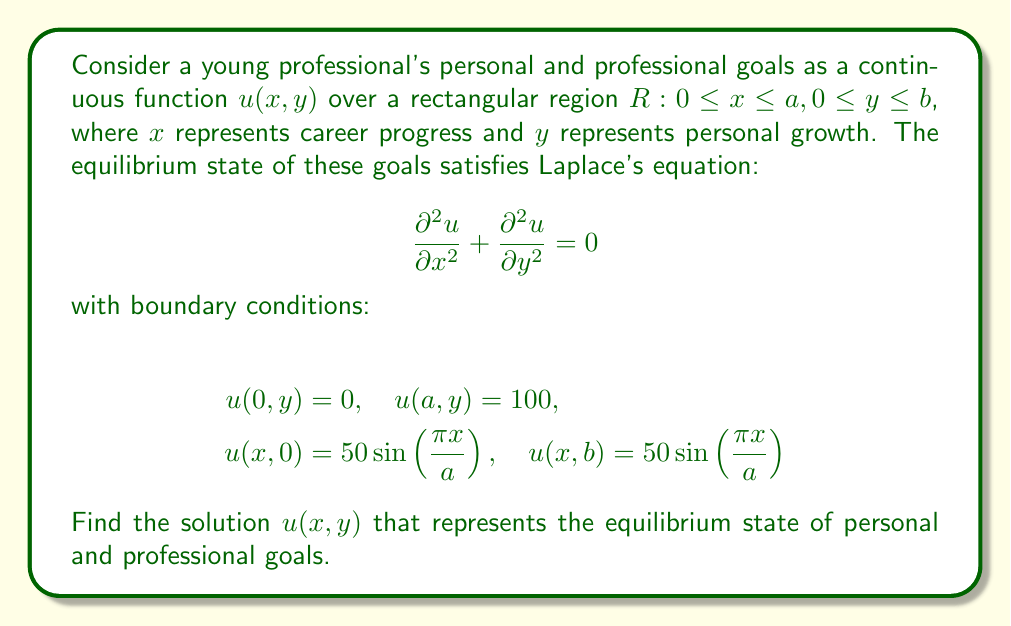Help me with this question. To solve this problem, we'll use the method of separation of variables.

1) Assume the solution has the form $u(x,y) = X(x)Y(y)$

2) Substituting into Laplace's equation:

   $$X''(x)Y(y) + X(x)Y''(y) = 0$$
   $$\frac{X''(x)}{X(x)} = -\frac{Y''(y)}{Y(y)} = -\lambda^2$$

3) This gives us two ODEs:
   $$X''(x) + \lambda^2X(x) = 0$$
   $$Y''(y) - \lambda^2Y(y) = 0$$

4) The general solutions are:
   $$X(x) = A\sin(\lambda x) + B\cos(\lambda x)$$
   $$Y(y) = Ce^{\lambda y} + De^{-\lambda y}$$

5) Applying the boundary conditions $u(0,y) = 0$ and $u(a,y) = 100$:
   $$X(0) = 0 \implies B = 0$$
   $$X(a) = 100 \implies A\sin(\lambda a) = 100$$

6) This means $\lambda = \frac{n\pi}{a}$ for $n = 1,2,3,...$

7) The solution that satisfies these conditions is:
   $$u(x,y) = \sum_{n=1}^{\infty} (C_n\sinh(\frac{n\pi y}{a}) + D_n\cosh(\frac{n\pi y}{a}))\sin(\frac{n\pi x}{a})$$

8) Applying the remaining boundary conditions:
   $$u(x,0) = 50\sin(\frac{\pi x}{a}) \implies D_1 = 50, D_n = 0 \text{ for } n > 1$$
   $$u(x,b) = 50\sin(\frac{\pi x}{a}) \implies C_1\sinh(\frac{\pi b}{a}) + 50\cosh(\frac{\pi b}{a}) = 50$$

9) Solving for $C_1$:
   $$C_1 = 50\frac{1-\cosh(\frac{\pi b}{a})}{\sinh(\frac{\pi b}{a})}$$

Therefore, the final solution is:
$$u(x,y) = 50\left(\frac{1-\cosh(\frac{\pi b}{a})}{\sinh(\frac{\pi b}{a})}\sinh(\frac{\pi y}{a}) + \cosh(\frac{\pi y}{a})\right)\sin(\frac{\pi x}{a})$$
Answer: $$u(x,y) = 50\left(\frac{1-\cosh(\frac{\pi b}{a})}{\sinh(\frac{\pi b}{a})}\sinh(\frac{\pi y}{a}) + \cosh(\frac{\pi y}{a})\right)\sin(\frac{\pi x}{a})$$ 